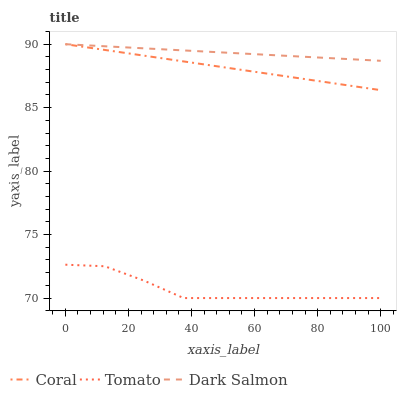Does Tomato have the minimum area under the curve?
Answer yes or no. Yes. Does Dark Salmon have the maximum area under the curve?
Answer yes or no. Yes. Does Coral have the minimum area under the curve?
Answer yes or no. No. Does Coral have the maximum area under the curve?
Answer yes or no. No. Is Dark Salmon the smoothest?
Answer yes or no. Yes. Is Tomato the roughest?
Answer yes or no. Yes. Is Coral the smoothest?
Answer yes or no. No. Is Coral the roughest?
Answer yes or no. No. Does Tomato have the lowest value?
Answer yes or no. Yes. Does Coral have the lowest value?
Answer yes or no. No. Does Dark Salmon have the highest value?
Answer yes or no. Yes. Is Tomato less than Dark Salmon?
Answer yes or no. Yes. Is Dark Salmon greater than Tomato?
Answer yes or no. Yes. Does Coral intersect Dark Salmon?
Answer yes or no. Yes. Is Coral less than Dark Salmon?
Answer yes or no. No. Is Coral greater than Dark Salmon?
Answer yes or no. No. Does Tomato intersect Dark Salmon?
Answer yes or no. No. 